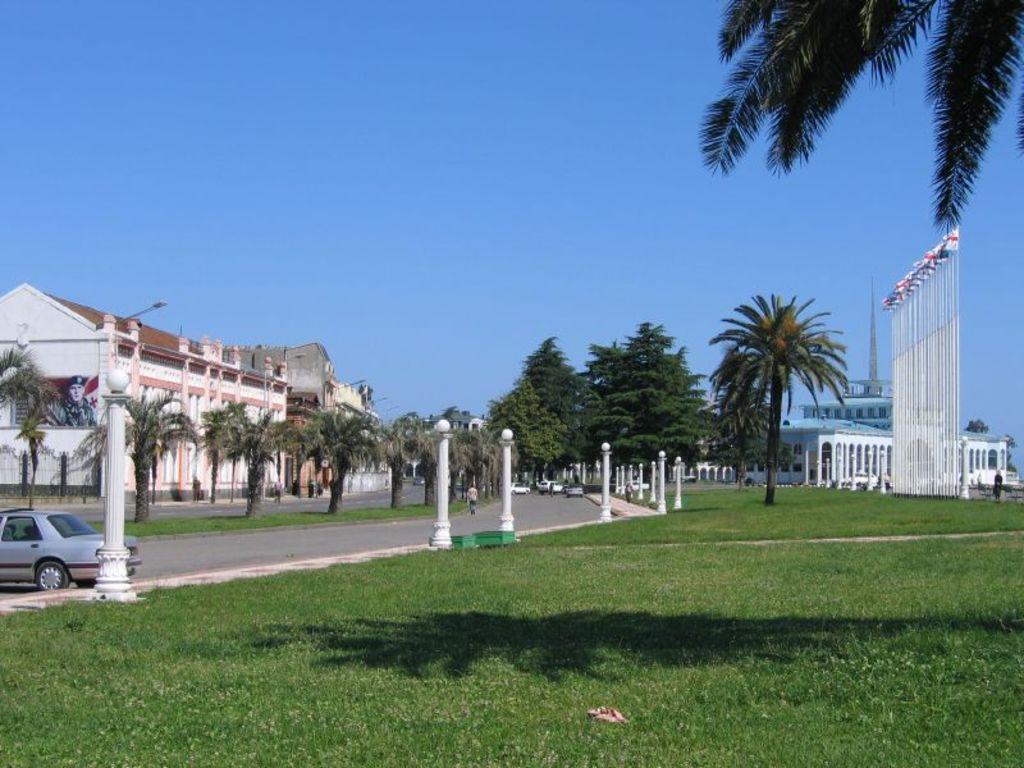In one or two sentences, can you explain what this image depicts? This is an outside view. At the bottom of the image I can see the grass. On the left side, I can see a car on the road. On both sides of the road I can see the pillars and the trees. In the background there are buildings. At the top I can see the sky. 